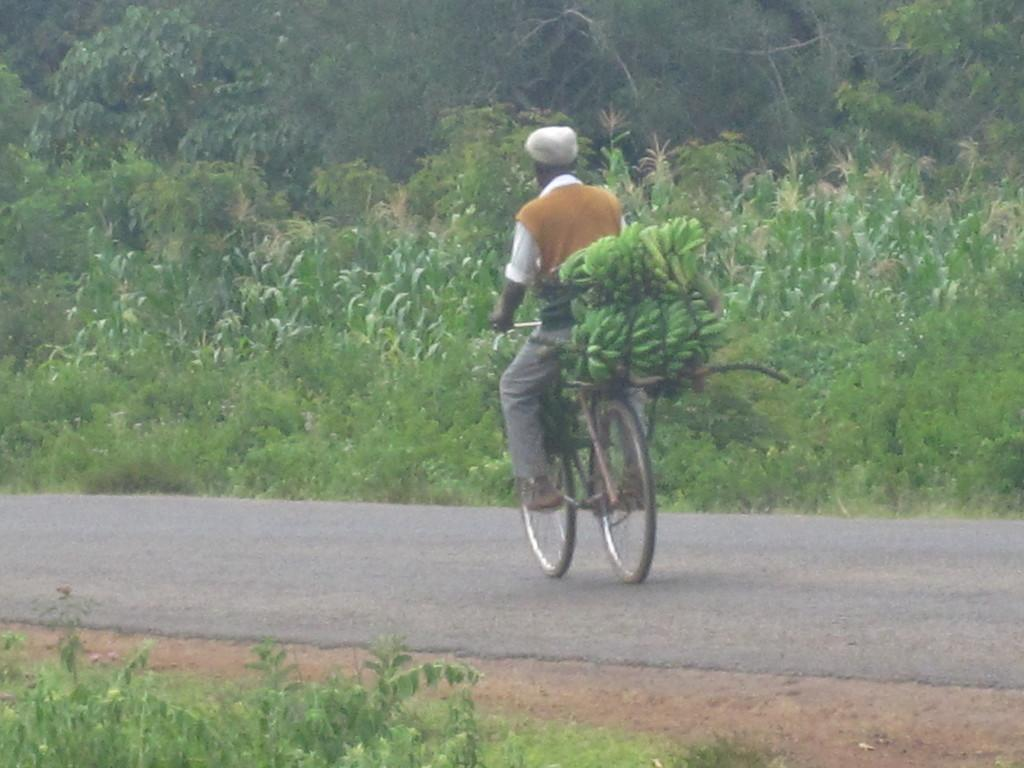What is the person in the image doing? There is a person riding a bicycle on the road in the image. What is placed on the bicycle? Bananas are placed on the bicycle. What type of vegetation can be seen in the image? Trees and plants are present in the image. What type of flesh can be seen hanging from the trees in the image? There is no flesh hanging from the trees in the image; only bananas are placed on the bicycle, and trees and plants are present. What type of hall is visible in the image? There is no hall present in the image; it features a person riding a bicycle, bananas on the bicycle, and vegetation. 